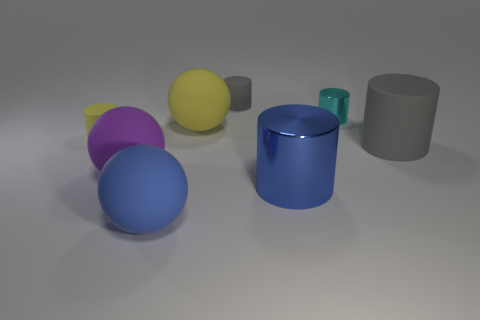Subtract all large blue cylinders. How many cylinders are left? 4 Add 1 yellow matte balls. How many objects exist? 9 Subtract all purple balls. How many balls are left? 2 Subtract all cylinders. How many objects are left? 3 Subtract all brown blocks. How many yellow cylinders are left? 1 Subtract all metallic cylinders. Subtract all tiny cyan shiny things. How many objects are left? 5 Add 1 small yellow cylinders. How many small yellow cylinders are left? 2 Add 1 big yellow metal balls. How many big yellow metal balls exist? 1 Subtract 0 red cylinders. How many objects are left? 8 Subtract all yellow spheres. Subtract all purple cylinders. How many spheres are left? 2 